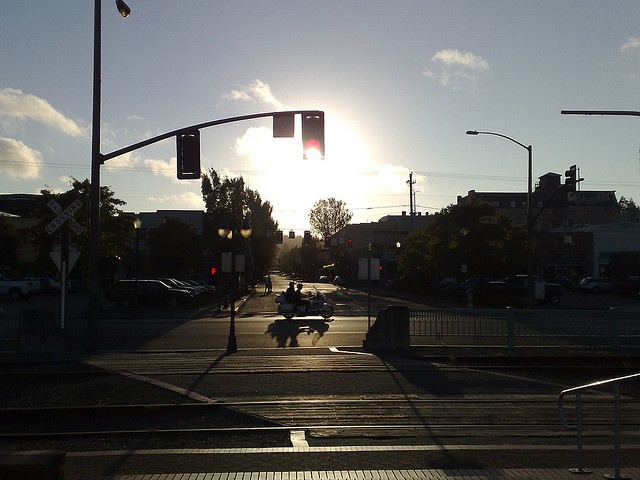Describe the objects in this image and their specific colors. I can see car in gray, black, and darkgray tones, truck in gray, black, and purple tones, traffic light in gray, black, and lightgray tones, traffic light in gray, white, and lightpink tones, and motorcycle in gray and black tones in this image. 